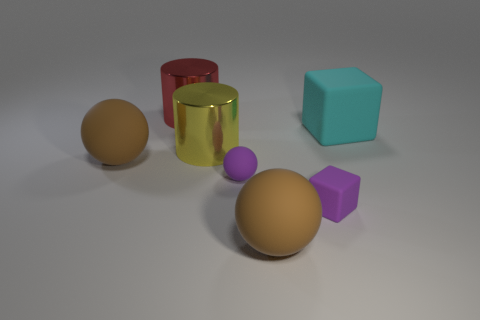Add 1 small rubber spheres. How many objects exist? 8 Subtract all blocks. How many objects are left? 5 Subtract all yellow shiny things. Subtract all cylinders. How many objects are left? 4 Add 1 brown matte spheres. How many brown matte spheres are left? 3 Add 6 small gray metallic cylinders. How many small gray metallic cylinders exist? 6 Subtract 0 purple cylinders. How many objects are left? 7 